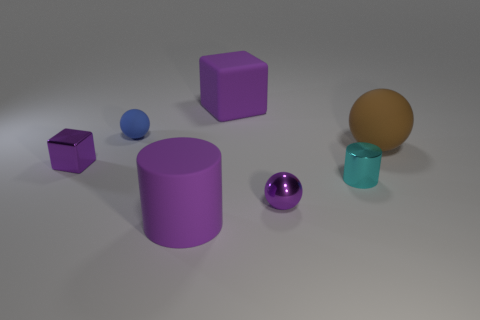Subtract all brown matte balls. How many balls are left? 2 Subtract all brown balls. How many balls are left? 2 Subtract 1 blocks. How many blocks are left? 1 Add 1 metal cylinders. How many objects exist? 8 Subtract all balls. How many objects are left? 4 Subtract all cyan cylinders. Subtract all brown blocks. How many cylinders are left? 1 Subtract all cyan balls. How many gray cylinders are left? 0 Subtract all red blocks. Subtract all purple shiny things. How many objects are left? 5 Add 5 purple matte objects. How many purple matte objects are left? 7 Add 1 green rubber objects. How many green rubber objects exist? 1 